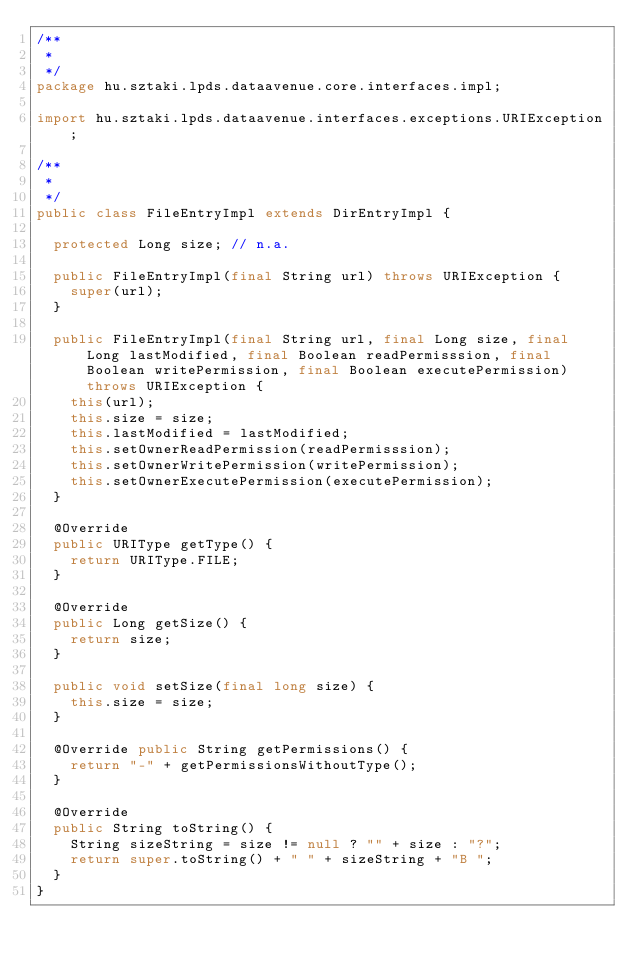<code> <loc_0><loc_0><loc_500><loc_500><_Java_>/**
 * 
 */
package hu.sztaki.lpds.dataavenue.core.interfaces.impl;

import hu.sztaki.lpds.dataavenue.interfaces.exceptions.URIException;

/**
 *
 */
public class FileEntryImpl extends DirEntryImpl {

	protected Long size; // n.a.
	
	public FileEntryImpl(final String url) throws URIException {
		super(url);
	}

	public FileEntryImpl(final String url, final Long size, final Long lastModified, final Boolean readPermisssion, final Boolean writePermission, final Boolean executePermission) throws URIException {
		this(url);
		this.size = size;
		this.lastModified = lastModified;
		this.setOwnerReadPermission(readPermisssion);
		this.setOwnerWritePermission(writePermission);
		this.setOwnerExecutePermission(executePermission);
	}
	
	@Override
	public URIType getType() {
		return URIType.FILE;
	}

	@Override
	public Long getSize() {
		return size; 
	}
	
	public void setSize(final long size) {
		this.size = size;
	}

	@Override public String getPermissions() {
		return "-" + getPermissionsWithoutType();
	}
	
	@Override
	public String toString() {
		String sizeString = size != null ? "" + size : "?";
		return super.toString() + " " + sizeString + "B ";
	}
}</code> 